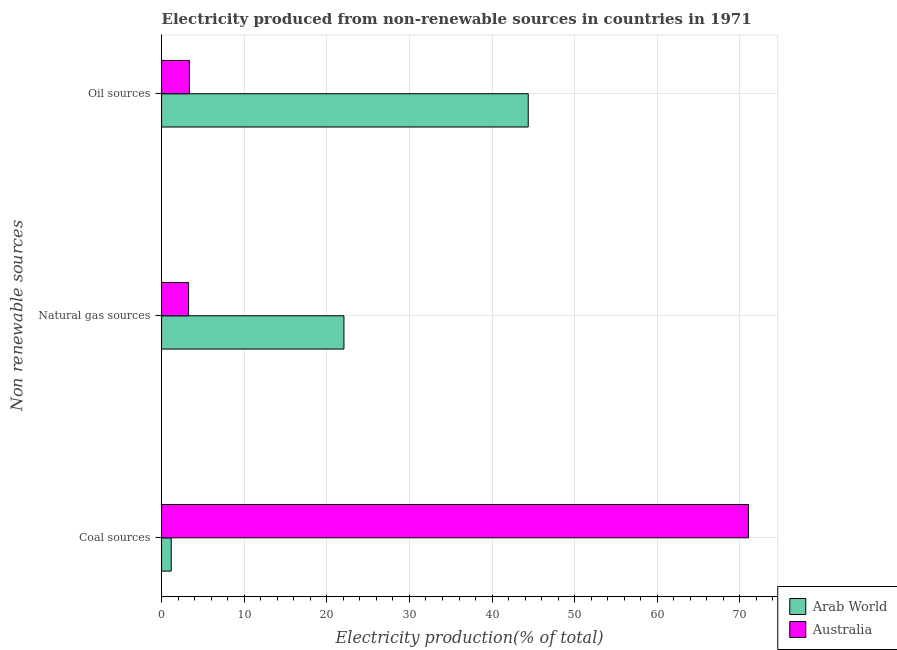How many different coloured bars are there?
Provide a succinct answer. 2. Are the number of bars per tick equal to the number of legend labels?
Your answer should be compact. Yes. Are the number of bars on each tick of the Y-axis equal?
Your answer should be compact. Yes. What is the label of the 2nd group of bars from the top?
Provide a succinct answer. Natural gas sources. What is the percentage of electricity produced by coal in Australia?
Offer a terse response. 71.03. Across all countries, what is the maximum percentage of electricity produced by coal?
Your answer should be very brief. 71.03. Across all countries, what is the minimum percentage of electricity produced by natural gas?
Your response must be concise. 3.27. In which country was the percentage of electricity produced by coal maximum?
Keep it short and to the point. Australia. In which country was the percentage of electricity produced by coal minimum?
Ensure brevity in your answer.  Arab World. What is the total percentage of electricity produced by oil sources in the graph?
Your answer should be very brief. 47.75. What is the difference between the percentage of electricity produced by oil sources in Australia and that in Arab World?
Give a very brief answer. -41.01. What is the difference between the percentage of electricity produced by natural gas in Australia and the percentage of electricity produced by oil sources in Arab World?
Provide a succinct answer. -41.11. What is the average percentage of electricity produced by coal per country?
Make the answer very short. 36.1. What is the difference between the percentage of electricity produced by natural gas and percentage of electricity produced by coal in Arab World?
Your answer should be compact. 20.91. What is the ratio of the percentage of electricity produced by coal in Arab World to that in Australia?
Make the answer very short. 0.02. Is the difference between the percentage of electricity produced by natural gas in Australia and Arab World greater than the difference between the percentage of electricity produced by coal in Australia and Arab World?
Give a very brief answer. No. What is the difference between the highest and the second highest percentage of electricity produced by natural gas?
Your response must be concise. 18.8. What is the difference between the highest and the lowest percentage of electricity produced by oil sources?
Make the answer very short. 41.01. Is the sum of the percentage of electricity produced by oil sources in Arab World and Australia greater than the maximum percentage of electricity produced by coal across all countries?
Your response must be concise. No. What does the 1st bar from the top in Natural gas sources represents?
Give a very brief answer. Australia. What does the 1st bar from the bottom in Coal sources represents?
Provide a succinct answer. Arab World. Is it the case that in every country, the sum of the percentage of electricity produced by coal and percentage of electricity produced by natural gas is greater than the percentage of electricity produced by oil sources?
Provide a short and direct response. No. Are the values on the major ticks of X-axis written in scientific E-notation?
Make the answer very short. No. Does the graph contain any zero values?
Make the answer very short. No. Where does the legend appear in the graph?
Your response must be concise. Bottom right. How many legend labels are there?
Keep it short and to the point. 2. How are the legend labels stacked?
Make the answer very short. Vertical. What is the title of the graph?
Your answer should be compact. Electricity produced from non-renewable sources in countries in 1971. Does "Eritrea" appear as one of the legend labels in the graph?
Your answer should be compact. No. What is the label or title of the X-axis?
Provide a short and direct response. Electricity production(% of total). What is the label or title of the Y-axis?
Your response must be concise. Non renewable sources. What is the Electricity production(% of total) in Arab World in Coal sources?
Your answer should be very brief. 1.17. What is the Electricity production(% of total) in Australia in Coal sources?
Your answer should be compact. 71.03. What is the Electricity production(% of total) of Arab World in Natural gas sources?
Offer a very short reply. 22.07. What is the Electricity production(% of total) in Australia in Natural gas sources?
Your answer should be very brief. 3.27. What is the Electricity production(% of total) in Arab World in Oil sources?
Offer a terse response. 44.38. What is the Electricity production(% of total) of Australia in Oil sources?
Offer a terse response. 3.37. Across all Non renewable sources, what is the maximum Electricity production(% of total) of Arab World?
Offer a terse response. 44.38. Across all Non renewable sources, what is the maximum Electricity production(% of total) of Australia?
Ensure brevity in your answer.  71.03. Across all Non renewable sources, what is the minimum Electricity production(% of total) in Arab World?
Ensure brevity in your answer.  1.17. Across all Non renewable sources, what is the minimum Electricity production(% of total) of Australia?
Provide a short and direct response. 3.27. What is the total Electricity production(% of total) of Arab World in the graph?
Offer a terse response. 67.62. What is the total Electricity production(% of total) of Australia in the graph?
Ensure brevity in your answer.  77.67. What is the difference between the Electricity production(% of total) in Arab World in Coal sources and that in Natural gas sources?
Your answer should be very brief. -20.91. What is the difference between the Electricity production(% of total) in Australia in Coal sources and that in Natural gas sources?
Keep it short and to the point. 67.76. What is the difference between the Electricity production(% of total) in Arab World in Coal sources and that in Oil sources?
Provide a succinct answer. -43.22. What is the difference between the Electricity production(% of total) of Australia in Coal sources and that in Oil sources?
Give a very brief answer. 67.66. What is the difference between the Electricity production(% of total) in Arab World in Natural gas sources and that in Oil sources?
Provide a short and direct response. -22.31. What is the difference between the Electricity production(% of total) of Australia in Natural gas sources and that in Oil sources?
Your response must be concise. -0.1. What is the difference between the Electricity production(% of total) in Arab World in Coal sources and the Electricity production(% of total) in Australia in Natural gas sources?
Give a very brief answer. -2.1. What is the difference between the Electricity production(% of total) in Arab World in Coal sources and the Electricity production(% of total) in Australia in Oil sources?
Make the answer very short. -2.2. What is the difference between the Electricity production(% of total) in Arab World in Natural gas sources and the Electricity production(% of total) in Australia in Oil sources?
Provide a succinct answer. 18.7. What is the average Electricity production(% of total) of Arab World per Non renewable sources?
Your answer should be very brief. 22.54. What is the average Electricity production(% of total) in Australia per Non renewable sources?
Your answer should be very brief. 25.89. What is the difference between the Electricity production(% of total) of Arab World and Electricity production(% of total) of Australia in Coal sources?
Keep it short and to the point. -69.87. What is the difference between the Electricity production(% of total) in Arab World and Electricity production(% of total) in Australia in Natural gas sources?
Ensure brevity in your answer.  18.8. What is the difference between the Electricity production(% of total) in Arab World and Electricity production(% of total) in Australia in Oil sources?
Make the answer very short. 41.01. What is the ratio of the Electricity production(% of total) in Arab World in Coal sources to that in Natural gas sources?
Give a very brief answer. 0.05. What is the ratio of the Electricity production(% of total) of Australia in Coal sources to that in Natural gas sources?
Provide a short and direct response. 21.73. What is the ratio of the Electricity production(% of total) in Arab World in Coal sources to that in Oil sources?
Give a very brief answer. 0.03. What is the ratio of the Electricity production(% of total) of Australia in Coal sources to that in Oil sources?
Give a very brief answer. 21.07. What is the ratio of the Electricity production(% of total) in Arab World in Natural gas sources to that in Oil sources?
Provide a succinct answer. 0.5. What is the ratio of the Electricity production(% of total) in Australia in Natural gas sources to that in Oil sources?
Your answer should be compact. 0.97. What is the difference between the highest and the second highest Electricity production(% of total) of Arab World?
Give a very brief answer. 22.31. What is the difference between the highest and the second highest Electricity production(% of total) of Australia?
Make the answer very short. 67.66. What is the difference between the highest and the lowest Electricity production(% of total) of Arab World?
Give a very brief answer. 43.22. What is the difference between the highest and the lowest Electricity production(% of total) in Australia?
Your answer should be very brief. 67.76. 